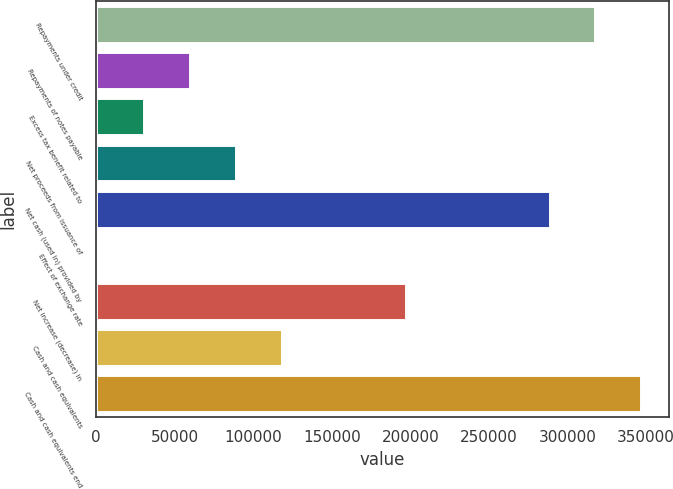<chart> <loc_0><loc_0><loc_500><loc_500><bar_chart><fcel>Repayments under credit<fcel>Repayments of notes payable<fcel>Excess tax benefit related to<fcel>Net proceeds from issuance of<fcel>Net cash (used in) provided by<fcel>Effect of exchange rate<fcel>Net increase (decrease) in<fcel>Cash and cash equivalents<fcel>Cash and cash equivalents end<nl><fcel>317812<fcel>59679.6<fcel>30491.3<fcel>88867.9<fcel>288624<fcel>1303<fcel>197525<fcel>118056<fcel>347001<nl></chart> 